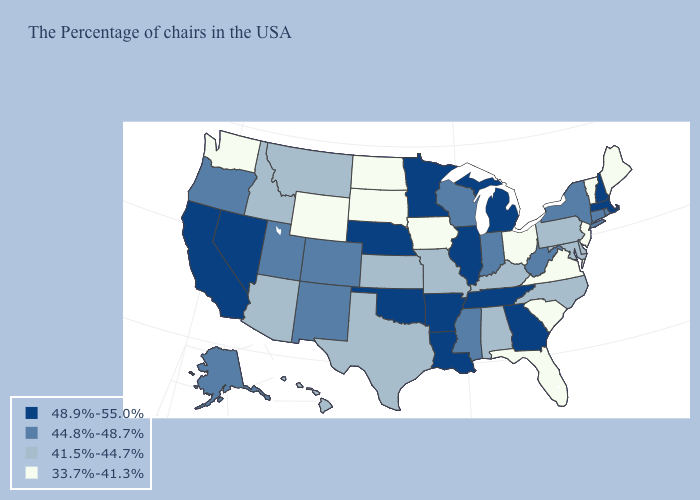Does New Jersey have the lowest value in the Northeast?
Short answer required. Yes. Does Pennsylvania have a lower value than Mississippi?
Answer briefly. Yes. Is the legend a continuous bar?
Answer briefly. No. What is the highest value in the West ?
Give a very brief answer. 48.9%-55.0%. What is the value of Florida?
Write a very short answer. 33.7%-41.3%. Which states have the lowest value in the Northeast?
Give a very brief answer. Maine, Vermont, New Jersey. Name the states that have a value in the range 33.7%-41.3%?
Be succinct. Maine, Vermont, New Jersey, Virginia, South Carolina, Ohio, Florida, Iowa, South Dakota, North Dakota, Wyoming, Washington. Is the legend a continuous bar?
Concise answer only. No. What is the lowest value in states that border Oklahoma?
Be succinct. 41.5%-44.7%. Does Oklahoma have the lowest value in the USA?
Quick response, please. No. Which states have the lowest value in the West?
Concise answer only. Wyoming, Washington. What is the lowest value in the Northeast?
Quick response, please. 33.7%-41.3%. Name the states that have a value in the range 41.5%-44.7%?
Write a very short answer. Delaware, Maryland, Pennsylvania, North Carolina, Kentucky, Alabama, Missouri, Kansas, Texas, Montana, Arizona, Idaho, Hawaii. Does the map have missing data?
Answer briefly. No. 